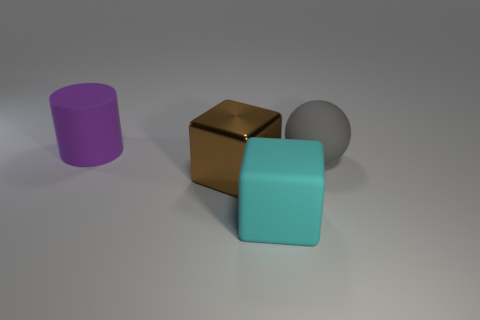Add 4 small red metallic blocks. How many objects exist? 8 Subtract all brown blocks. How many blocks are left? 1 Subtract all large blue metallic objects. Subtract all big purple matte cylinders. How many objects are left? 3 Add 1 big gray balls. How many big gray balls are left? 2 Add 2 small brown cylinders. How many small brown cylinders exist? 2 Subtract 0 brown cylinders. How many objects are left? 4 Subtract all blue cylinders. Subtract all blue balls. How many cylinders are left? 1 Subtract all green cubes. How many red cylinders are left? 0 